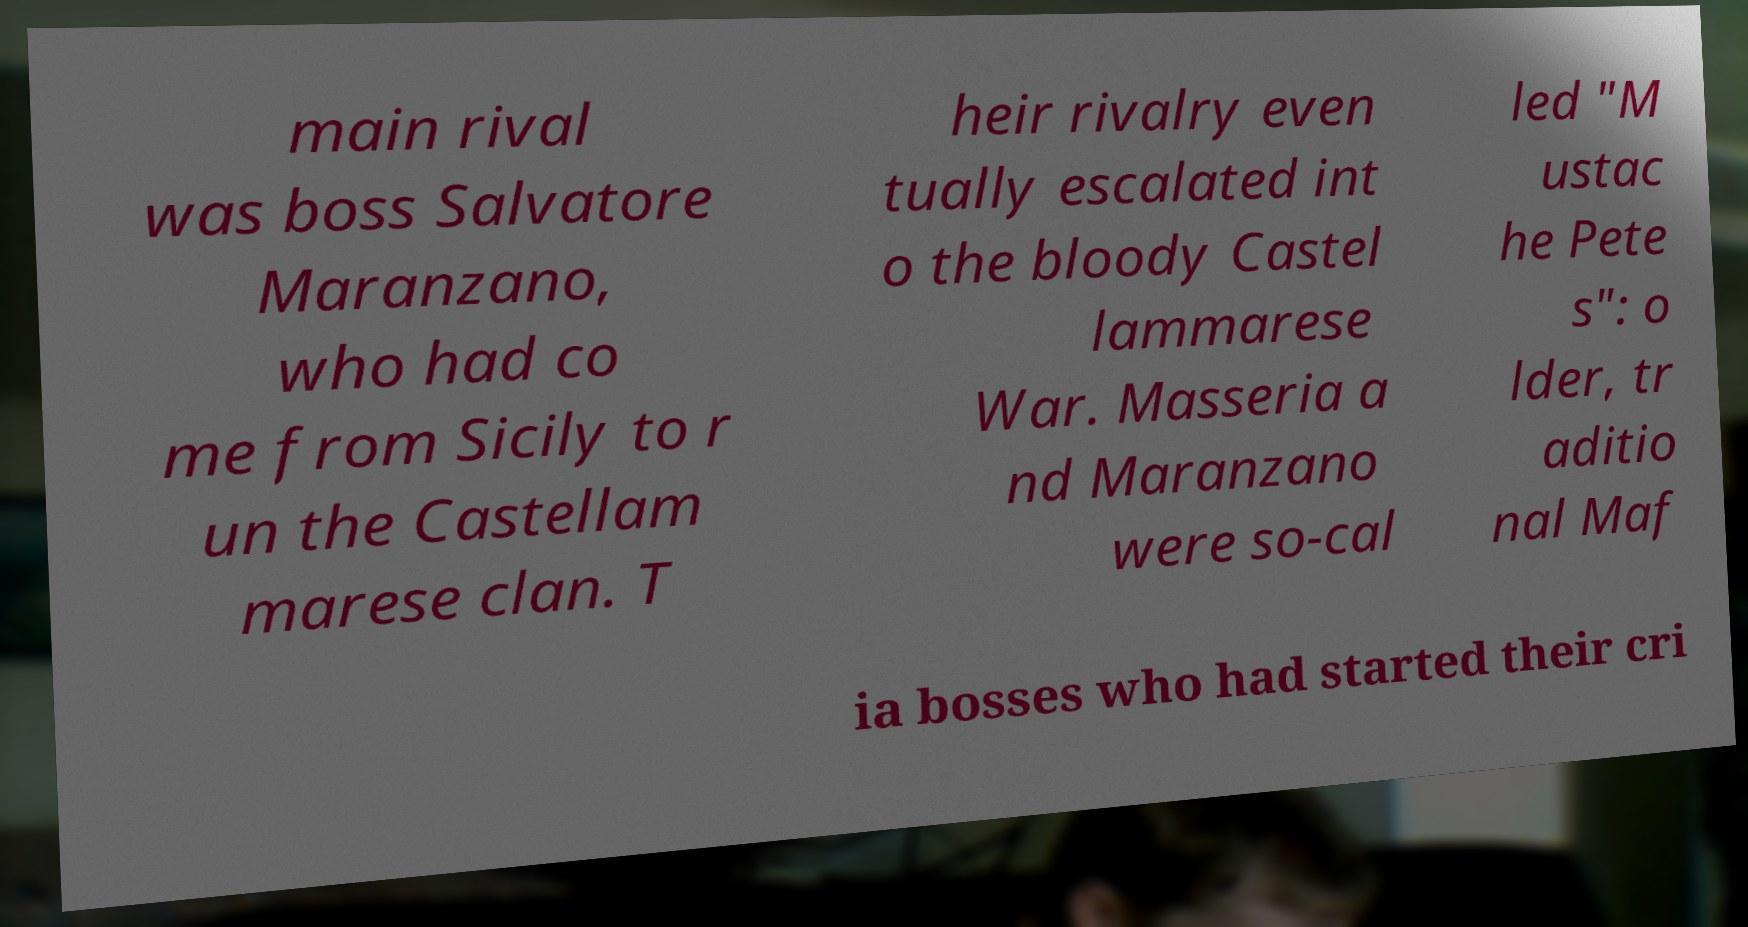What messages or text are displayed in this image? I need them in a readable, typed format. main rival was boss Salvatore Maranzano, who had co me from Sicily to r un the Castellam marese clan. T heir rivalry even tually escalated int o the bloody Castel lammarese War. Masseria a nd Maranzano were so-cal led "M ustac he Pete s": o lder, tr aditio nal Maf ia bosses who had started their cri 